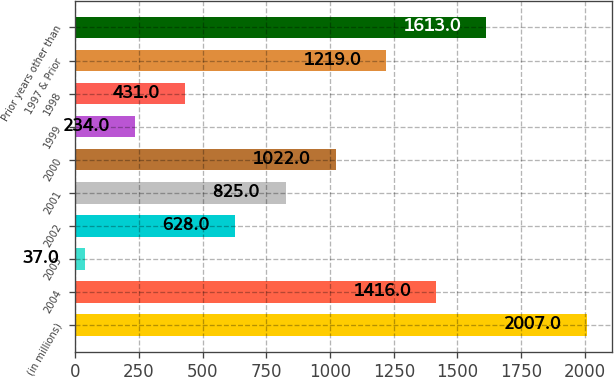<chart> <loc_0><loc_0><loc_500><loc_500><bar_chart><fcel>(in millions)<fcel>2004<fcel>2003<fcel>2002<fcel>2001<fcel>2000<fcel>1999<fcel>1998<fcel>1997 & Prior<fcel>Prior years other than<nl><fcel>2007<fcel>1416<fcel>37<fcel>628<fcel>825<fcel>1022<fcel>234<fcel>431<fcel>1219<fcel>1613<nl></chart> 